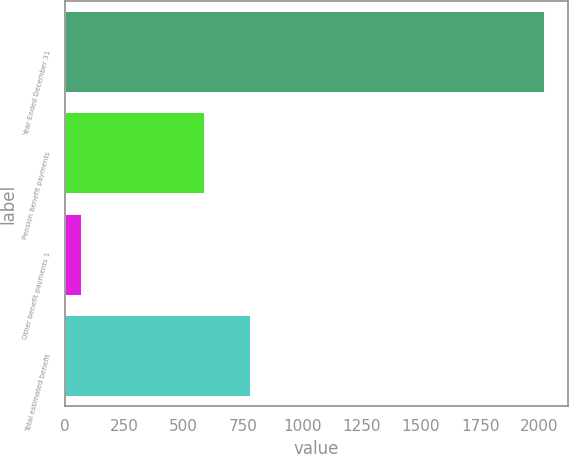Convert chart to OTSL. <chart><loc_0><loc_0><loc_500><loc_500><bar_chart><fcel>Year Ended December 31<fcel>Pension benefit payments<fcel>Other benefit payments 1<fcel>Total estimated benefit<nl><fcel>2019<fcel>584<fcel>68<fcel>779.1<nl></chart> 